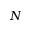Convert formula to latex. <formula><loc_0><loc_0><loc_500><loc_500>N</formula> 